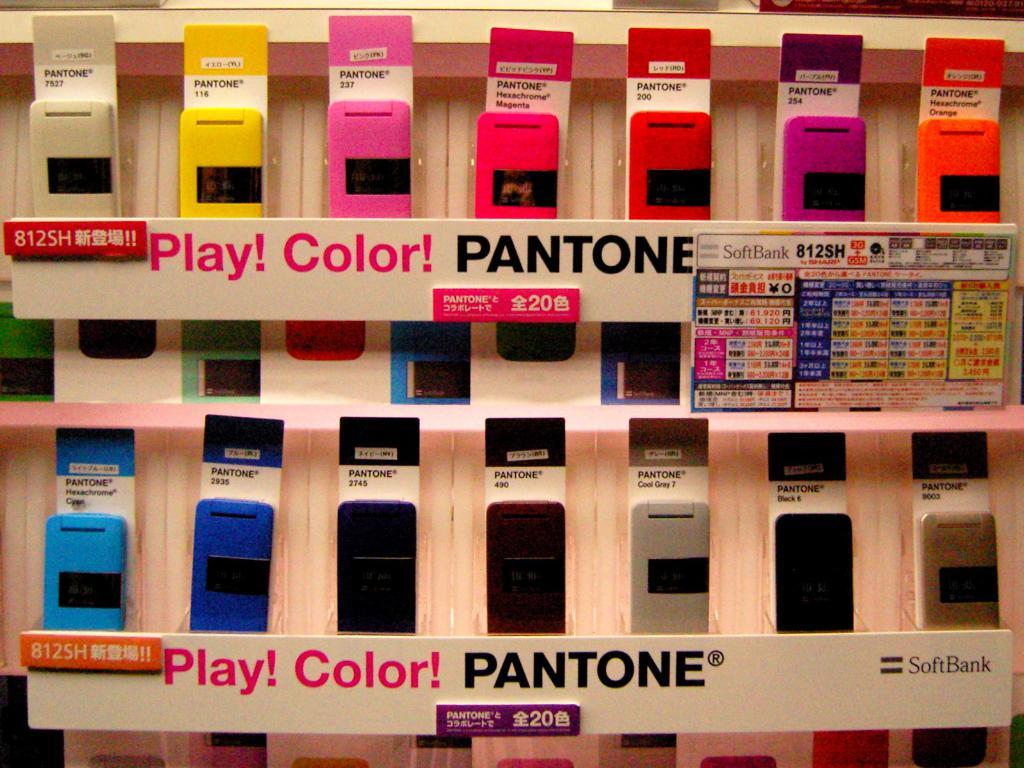What brand of phone are these?
Make the answer very short. Pantone. What are the words in pink?
Offer a very short reply. Play! color!. 